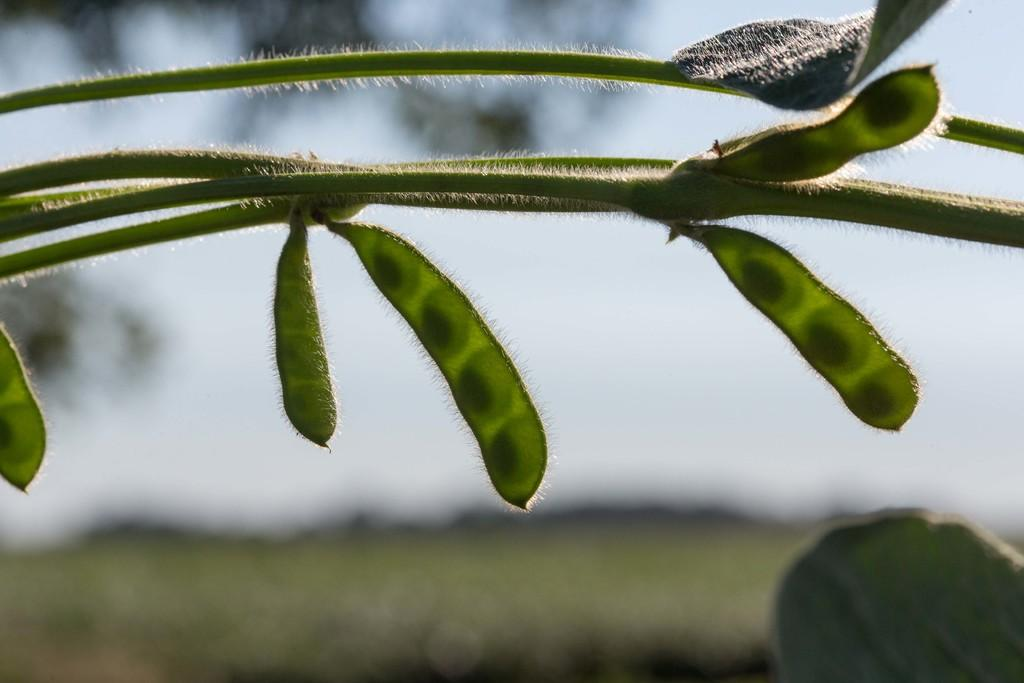What is present in the image? There is a plant in the image. Can you describe the background of the image? The background of the image is blurry. What type of record can be seen playing on the boat in the image? There is no record or boat present in the image; it only features a plant and a blurry background. 